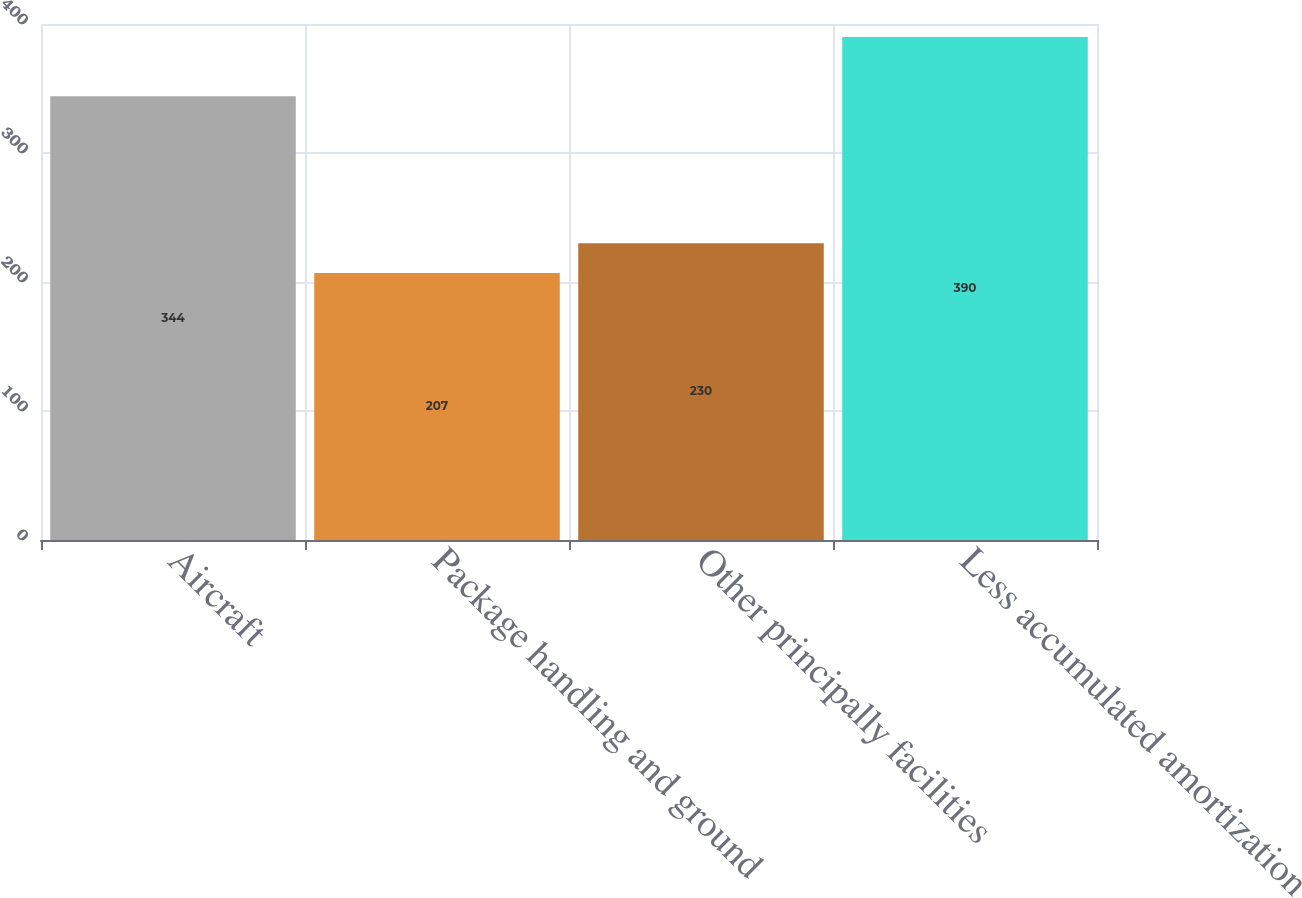<chart> <loc_0><loc_0><loc_500><loc_500><bar_chart><fcel>Aircraft<fcel>Package handling and ground<fcel>Other principally facilities<fcel>Less accumulated amortization<nl><fcel>344<fcel>207<fcel>230<fcel>390<nl></chart> 